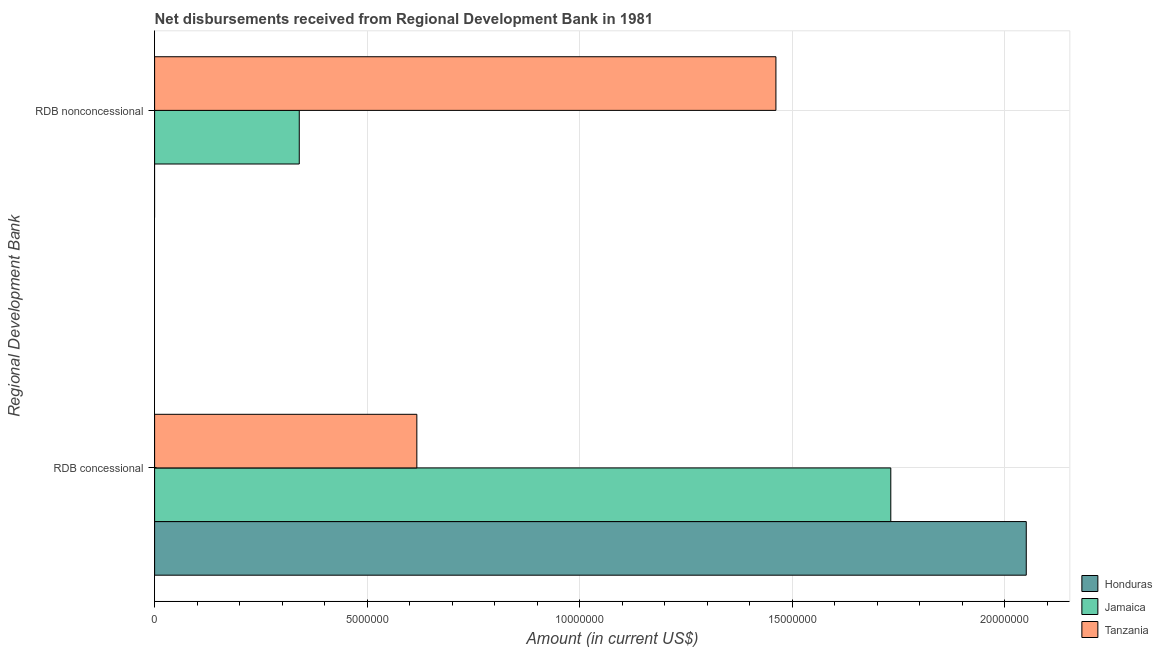How many different coloured bars are there?
Your answer should be compact. 3. How many groups of bars are there?
Provide a short and direct response. 2. How many bars are there on the 1st tick from the top?
Your response must be concise. 2. How many bars are there on the 1st tick from the bottom?
Provide a succinct answer. 3. What is the label of the 2nd group of bars from the top?
Ensure brevity in your answer.  RDB concessional. What is the net concessional disbursements from rdb in Honduras?
Provide a short and direct response. 2.05e+07. Across all countries, what is the maximum net non concessional disbursements from rdb?
Offer a very short reply. 1.46e+07. Across all countries, what is the minimum net concessional disbursements from rdb?
Ensure brevity in your answer.  6.17e+06. In which country was the net concessional disbursements from rdb maximum?
Your response must be concise. Honduras. What is the total net concessional disbursements from rdb in the graph?
Your answer should be very brief. 4.40e+07. What is the difference between the net concessional disbursements from rdb in Tanzania and that in Honduras?
Offer a very short reply. -1.43e+07. What is the difference between the net concessional disbursements from rdb in Honduras and the net non concessional disbursements from rdb in Tanzania?
Your answer should be very brief. 5.89e+06. What is the average net concessional disbursements from rdb per country?
Give a very brief answer. 1.47e+07. What is the difference between the net non concessional disbursements from rdb and net concessional disbursements from rdb in Jamaica?
Your answer should be compact. -1.39e+07. In how many countries, is the net concessional disbursements from rdb greater than 1000000 US$?
Offer a terse response. 3. What is the ratio of the net concessional disbursements from rdb in Honduras to that in Tanzania?
Ensure brevity in your answer.  3.32. Is the net concessional disbursements from rdb in Tanzania less than that in Honduras?
Your response must be concise. Yes. In how many countries, is the net concessional disbursements from rdb greater than the average net concessional disbursements from rdb taken over all countries?
Keep it short and to the point. 2. How many bars are there?
Offer a very short reply. 5. How many countries are there in the graph?
Your answer should be compact. 3. What is the difference between two consecutive major ticks on the X-axis?
Ensure brevity in your answer.  5.00e+06. Are the values on the major ticks of X-axis written in scientific E-notation?
Keep it short and to the point. No. How are the legend labels stacked?
Ensure brevity in your answer.  Vertical. What is the title of the graph?
Ensure brevity in your answer.  Net disbursements received from Regional Development Bank in 1981. What is the label or title of the Y-axis?
Your response must be concise. Regional Development Bank. What is the Amount (in current US$) of Honduras in RDB concessional?
Give a very brief answer. 2.05e+07. What is the Amount (in current US$) of Jamaica in RDB concessional?
Your answer should be very brief. 1.73e+07. What is the Amount (in current US$) of Tanzania in RDB concessional?
Provide a short and direct response. 6.17e+06. What is the Amount (in current US$) of Jamaica in RDB nonconcessional?
Make the answer very short. 3.40e+06. What is the Amount (in current US$) in Tanzania in RDB nonconcessional?
Provide a succinct answer. 1.46e+07. Across all Regional Development Bank, what is the maximum Amount (in current US$) of Honduras?
Offer a very short reply. 2.05e+07. Across all Regional Development Bank, what is the maximum Amount (in current US$) of Jamaica?
Offer a terse response. 1.73e+07. Across all Regional Development Bank, what is the maximum Amount (in current US$) of Tanzania?
Your response must be concise. 1.46e+07. Across all Regional Development Bank, what is the minimum Amount (in current US$) in Jamaica?
Your response must be concise. 3.40e+06. Across all Regional Development Bank, what is the minimum Amount (in current US$) in Tanzania?
Offer a very short reply. 6.17e+06. What is the total Amount (in current US$) of Honduras in the graph?
Provide a succinct answer. 2.05e+07. What is the total Amount (in current US$) of Jamaica in the graph?
Provide a succinct answer. 2.07e+07. What is the total Amount (in current US$) in Tanzania in the graph?
Provide a succinct answer. 2.08e+07. What is the difference between the Amount (in current US$) in Jamaica in RDB concessional and that in RDB nonconcessional?
Offer a very short reply. 1.39e+07. What is the difference between the Amount (in current US$) of Tanzania in RDB concessional and that in RDB nonconcessional?
Keep it short and to the point. -8.45e+06. What is the difference between the Amount (in current US$) of Honduras in RDB concessional and the Amount (in current US$) of Jamaica in RDB nonconcessional?
Make the answer very short. 1.71e+07. What is the difference between the Amount (in current US$) in Honduras in RDB concessional and the Amount (in current US$) in Tanzania in RDB nonconcessional?
Your answer should be compact. 5.89e+06. What is the difference between the Amount (in current US$) of Jamaica in RDB concessional and the Amount (in current US$) of Tanzania in RDB nonconcessional?
Provide a short and direct response. 2.70e+06. What is the average Amount (in current US$) in Honduras per Regional Development Bank?
Your response must be concise. 1.03e+07. What is the average Amount (in current US$) of Jamaica per Regional Development Bank?
Provide a short and direct response. 1.04e+07. What is the average Amount (in current US$) of Tanzania per Regional Development Bank?
Provide a short and direct response. 1.04e+07. What is the difference between the Amount (in current US$) of Honduras and Amount (in current US$) of Jamaica in RDB concessional?
Make the answer very short. 3.19e+06. What is the difference between the Amount (in current US$) in Honduras and Amount (in current US$) in Tanzania in RDB concessional?
Make the answer very short. 1.43e+07. What is the difference between the Amount (in current US$) of Jamaica and Amount (in current US$) of Tanzania in RDB concessional?
Ensure brevity in your answer.  1.12e+07. What is the difference between the Amount (in current US$) of Jamaica and Amount (in current US$) of Tanzania in RDB nonconcessional?
Your answer should be compact. -1.12e+07. What is the ratio of the Amount (in current US$) of Jamaica in RDB concessional to that in RDB nonconcessional?
Give a very brief answer. 5.09. What is the ratio of the Amount (in current US$) in Tanzania in RDB concessional to that in RDB nonconcessional?
Your answer should be very brief. 0.42. What is the difference between the highest and the second highest Amount (in current US$) in Jamaica?
Provide a succinct answer. 1.39e+07. What is the difference between the highest and the second highest Amount (in current US$) in Tanzania?
Your answer should be very brief. 8.45e+06. What is the difference between the highest and the lowest Amount (in current US$) in Honduras?
Ensure brevity in your answer.  2.05e+07. What is the difference between the highest and the lowest Amount (in current US$) in Jamaica?
Offer a terse response. 1.39e+07. What is the difference between the highest and the lowest Amount (in current US$) of Tanzania?
Ensure brevity in your answer.  8.45e+06. 